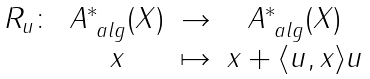Convert formula to latex. <formula><loc_0><loc_0><loc_500><loc_500>\begin{matrix} R _ { u } \colon & A ^ { * } _ { \ a l g } ( X ) & \to & A ^ { * } _ { \ a l g } ( X ) \\ & x & \mapsto & x + \langle u , x \rangle u \end{matrix}</formula> 